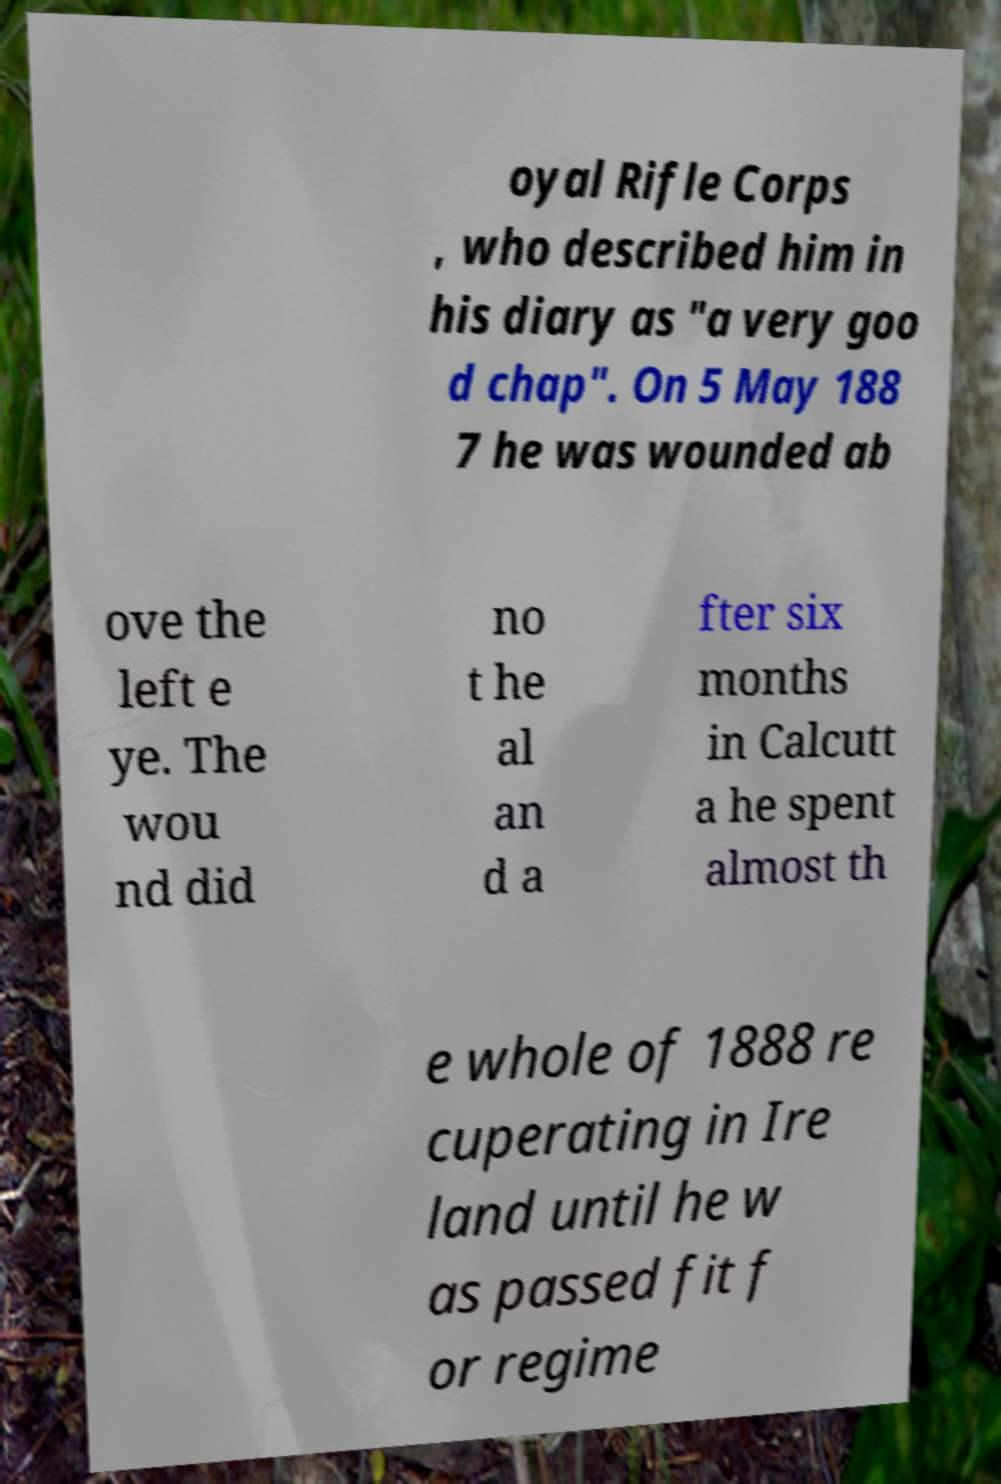For documentation purposes, I need the text within this image transcribed. Could you provide that? oyal Rifle Corps , who described him in his diary as "a very goo d chap". On 5 May 188 7 he was wounded ab ove the left e ye. The wou nd did no t he al an d a fter six months in Calcutt a he spent almost th e whole of 1888 re cuperating in Ire land until he w as passed fit f or regime 